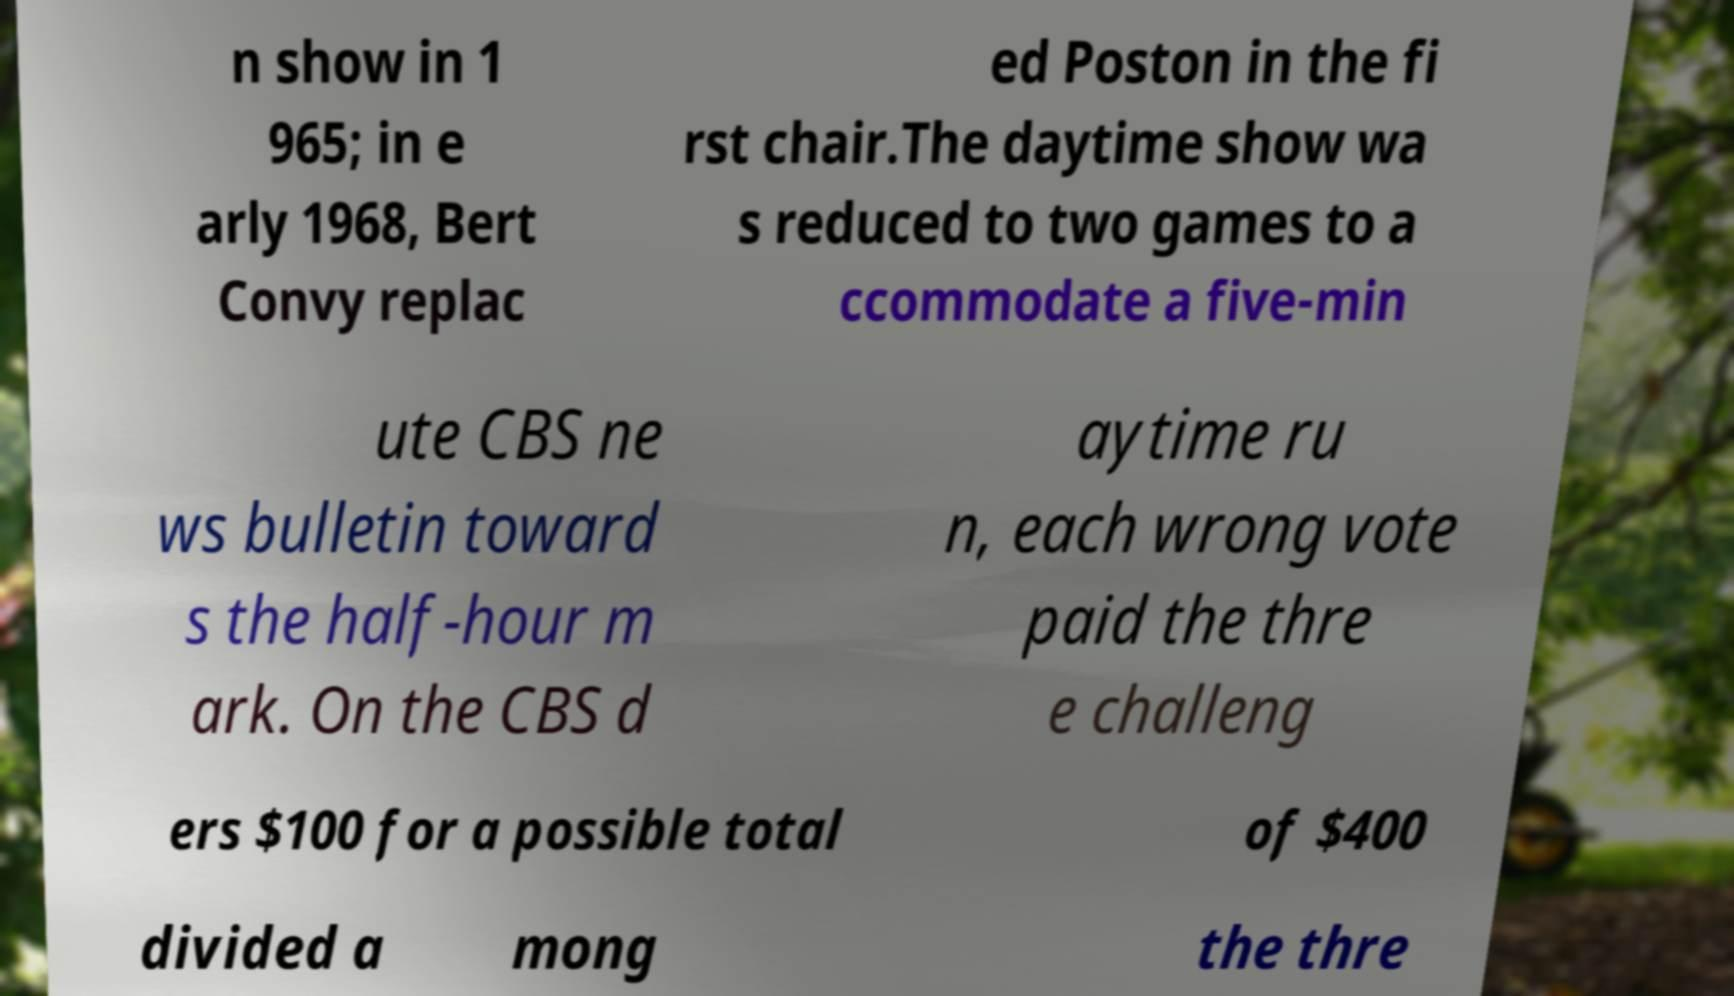Could you extract and type out the text from this image? n show in 1 965; in e arly 1968, Bert Convy replac ed Poston in the fi rst chair.The daytime show wa s reduced to two games to a ccommodate a five-min ute CBS ne ws bulletin toward s the half-hour m ark. On the CBS d aytime ru n, each wrong vote paid the thre e challeng ers $100 for a possible total of $400 divided a mong the thre 